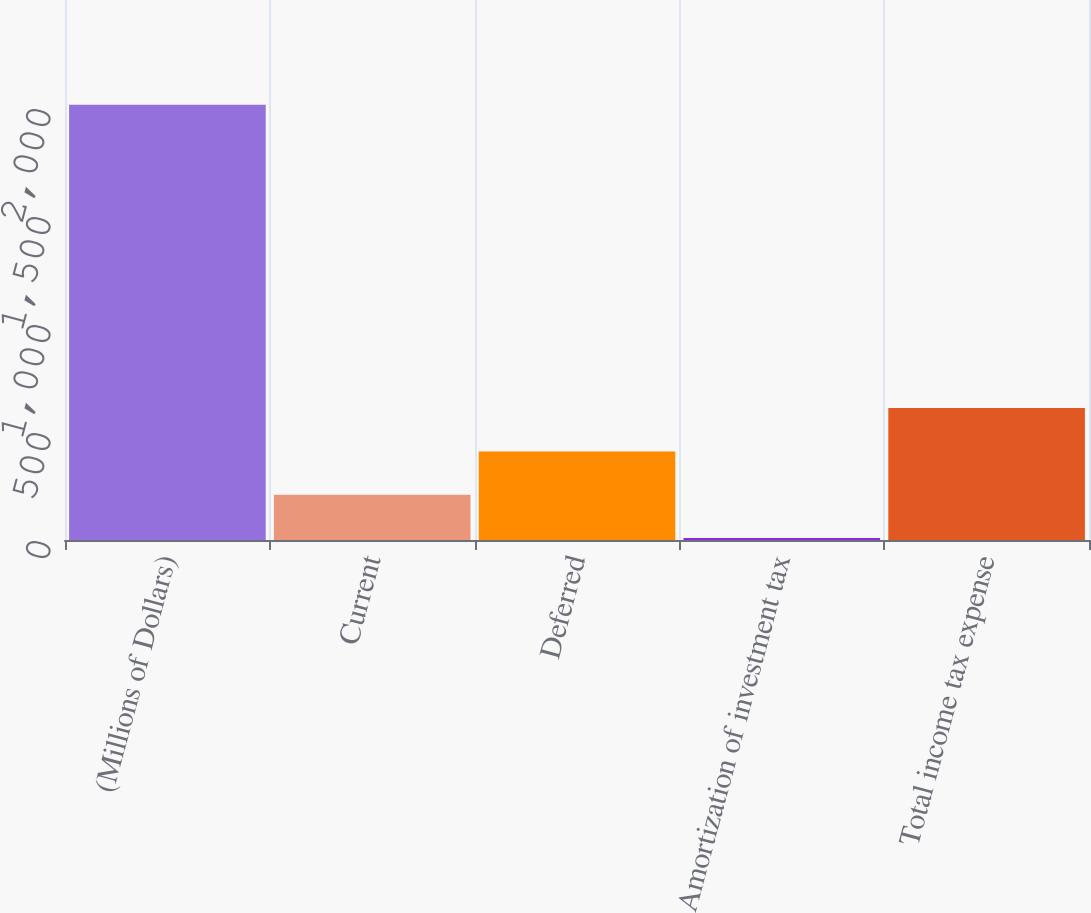Convert chart. <chart><loc_0><loc_0><loc_500><loc_500><bar_chart><fcel>(Millions of Dollars)<fcel>Current<fcel>Deferred<fcel>Amortization of investment tax<fcel>Total income tax expense<nl><fcel>2015<fcel>209.6<fcel>410.2<fcel>9<fcel>610.8<nl></chart> 